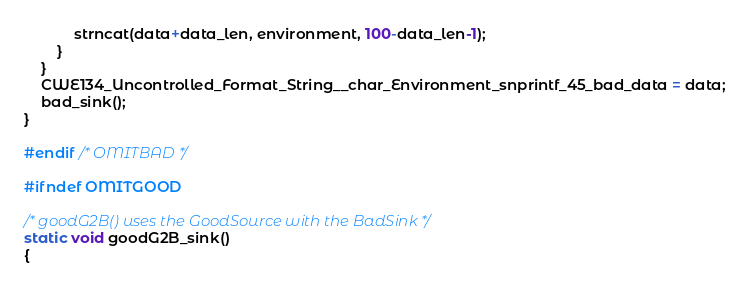Convert code to text. <code><loc_0><loc_0><loc_500><loc_500><_C_>            strncat(data+data_len, environment, 100-data_len-1);
        }
    }
    CWE134_Uncontrolled_Format_String__char_Environment_snprintf_45_bad_data = data;
    bad_sink();
}

#endif /* OMITBAD */

#ifndef OMITGOOD

/* goodG2B() uses the GoodSource with the BadSink */
static void goodG2B_sink()
{</code> 